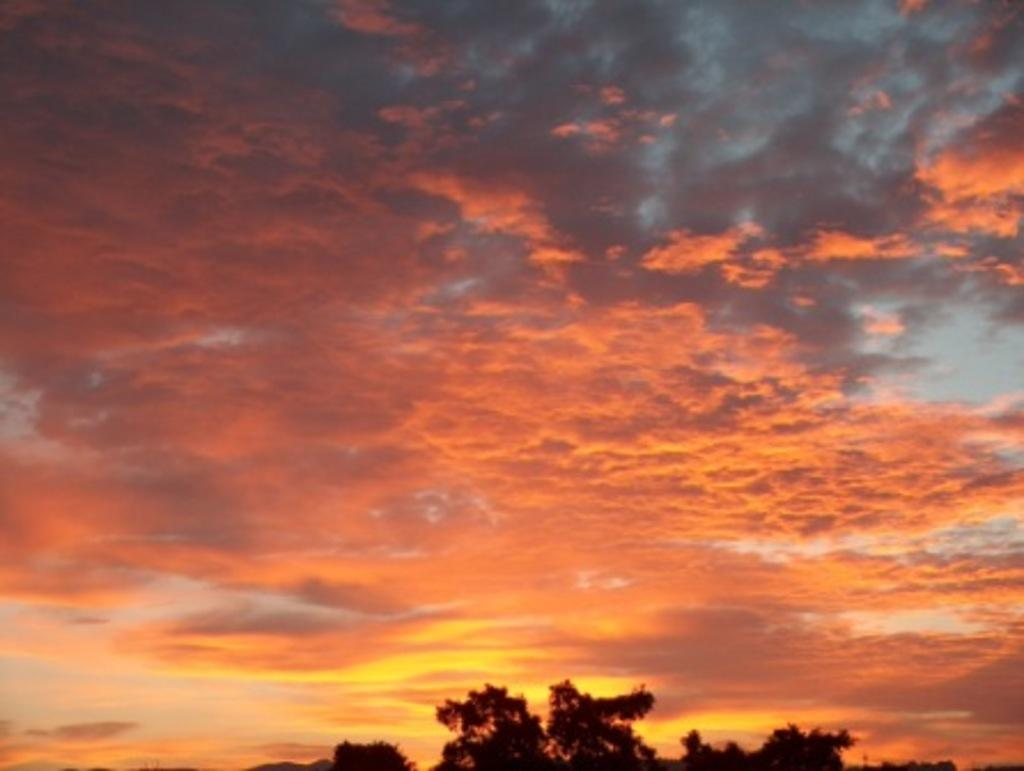What can be seen in the sky in the image? There are clouds in the sky in the image. What type of vegetation is visible at the bottom of the image? There are trees visible at the bottom of the image. How many chairs are balanced on the clouds in the image? There are no chairs present in the image, and therefore no chairs can be balanced on the clouds. 